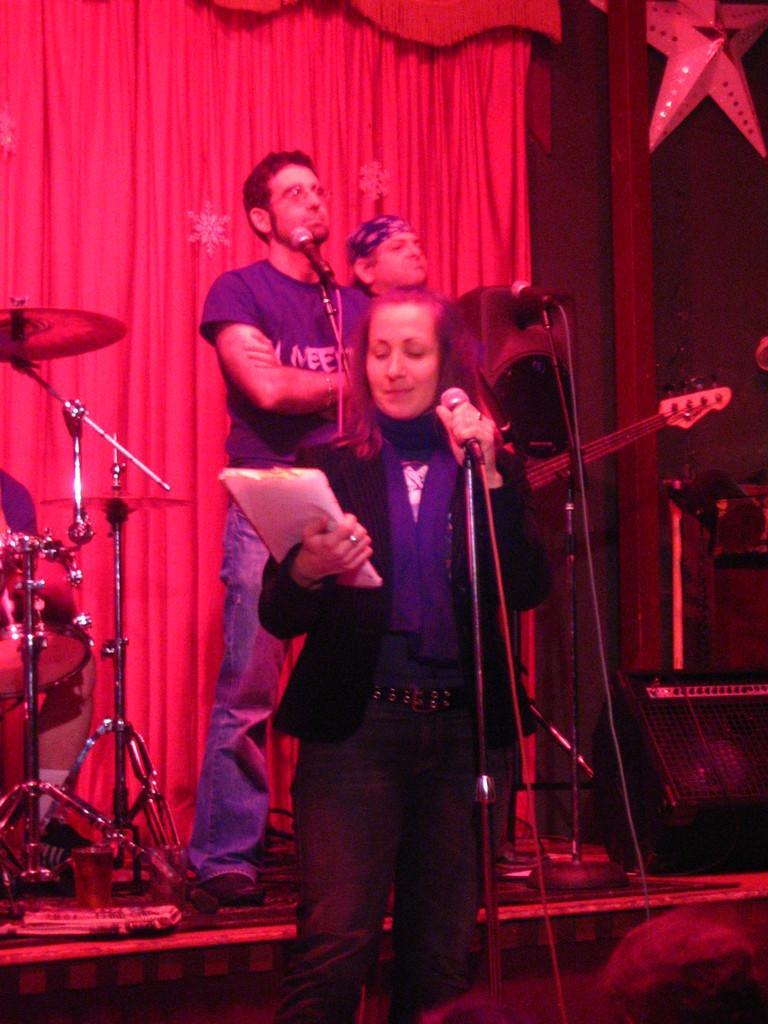In one or two sentences, can you explain what this image depicts? There are three people standing. I can see the miles, which are attached to the mike stands. This woman is holding a paper and a mike in her hands. I think this is a guitar. These look like the drums. This is a stage. I can see a curtain hanging. At the top right side of the image, I can see an artificial star. 